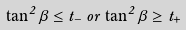Convert formula to latex. <formula><loc_0><loc_0><loc_500><loc_500>\tan ^ { 2 } \beta \leq t _ { - } \, o r \, \tan ^ { 2 } \beta \geq t _ { + }</formula> 